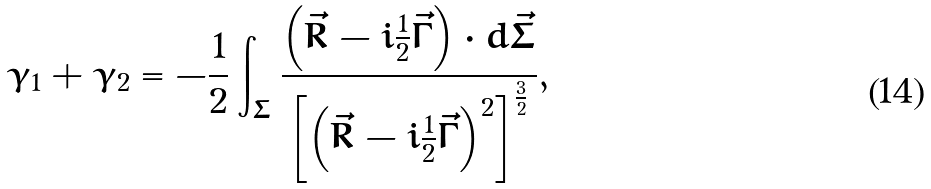<formula> <loc_0><loc_0><loc_500><loc_500>\gamma _ { 1 } + \gamma _ { 2 } = - \frac { 1 } { 2 } \int _ { \Sigma } \frac { \left ( \vec { R } - i \frac { 1 } { 2 } \vec { \Gamma } \right ) \cdot d \vec { \Sigma } } { \left [ \left ( \vec { R } - i \frac { 1 } { 2 } \vec { \Gamma } \right ) ^ { 2 } \right ] ^ { \frac { 3 } { 2 } } } ,</formula> 